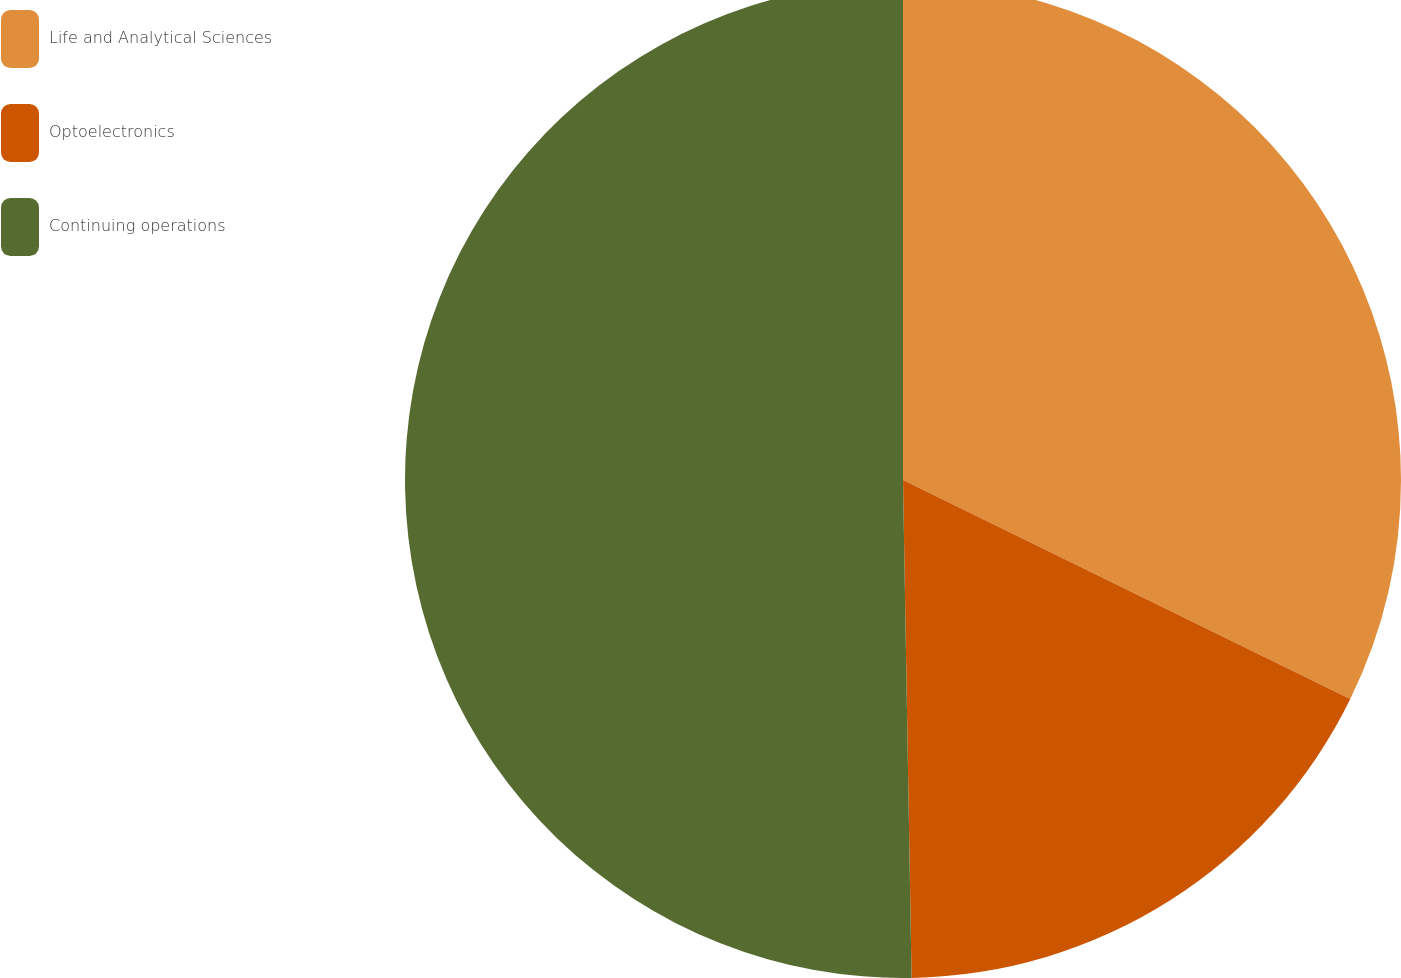Convert chart. <chart><loc_0><loc_0><loc_500><loc_500><pie_chart><fcel>Life and Analytical Sciences<fcel>Optoelectronics<fcel>Continuing operations<nl><fcel>32.25%<fcel>17.48%<fcel>50.28%<nl></chart> 